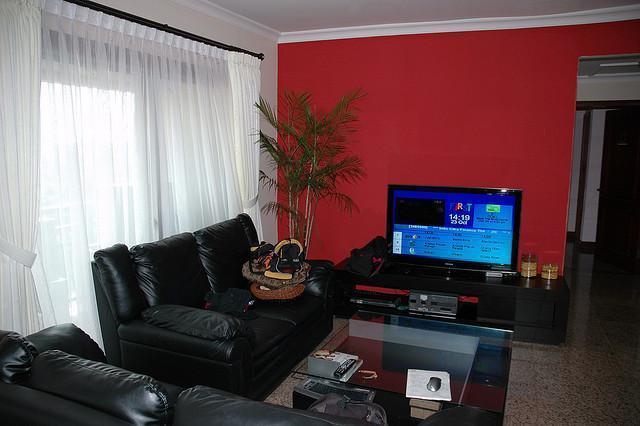How many monitors are there?
Give a very brief answer. 1. How many couches are there?
Give a very brief answer. 2. How many knives can you see?
Give a very brief answer. 0. 